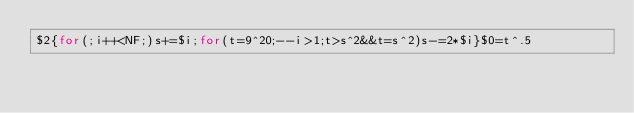<code> <loc_0><loc_0><loc_500><loc_500><_Awk_>$2{for(;i++<NF;)s+=$i;for(t=9^20;--i>1;t>s^2&&t=s^2)s-=2*$i}$0=t^.5</code> 